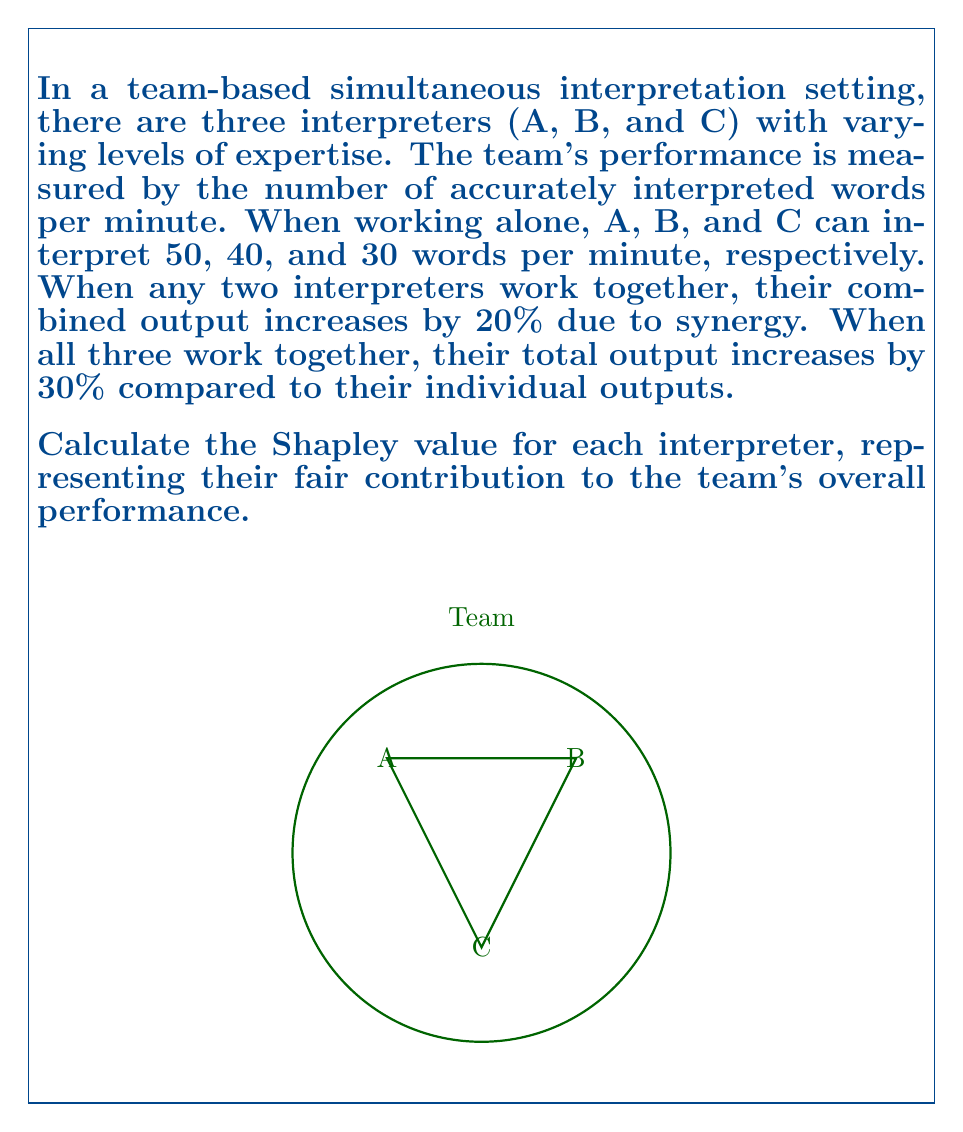Give your solution to this math problem. To calculate the Shapley value, we need to consider all possible coalitions and the marginal contributions of each interpreter. Let's follow these steps:

1. Calculate the value of each coalition:
   - v(A) = 50, v(B) = 40, v(C) = 30
   - v(AB) = (50 + 40) * 1.2 = 108
   - v(AC) = (50 + 30) * 1.2 = 96
   - v(BC) = (40 + 30) * 1.2 = 84
   - v(ABC) = (50 + 40 + 30) * 1.3 = 156

2. List all possible orderings of interpreters (6 in total):
   ABC, ACB, BAC, BCA, CAB, CBA

3. Calculate marginal contributions for each interpreter in each ordering:
   ABC: A(50), B(58), C(48)
   ACB: A(50), C(46), B(60)
   BAC: B(40), A(68), C(48)
   BCA: B(40), C(44), A(72)
   CAB: C(30), A(66), B(60)
   CBA: C(30), B(54), A(72)

4. Calculate the Shapley value for each interpreter:
   Shapley value = (sum of marginal contributions) / (number of orderings)

   For A: $\phi_A = \frac{50 + 50 + 68 + 72 + 66 + 72}{6} = 63$

   For B: $\phi_B = \frac{58 + 60 + 40 + 40 + 60 + 54}{6} = 52$

   For C: $\phi_C = \frac{48 + 46 + 48 + 44 + 30 + 30}{6} = 41$

5. Verify that the Shapley values sum up to the grand coalition value:
   $63 + 52 + 41 = 156 = v(ABC)$

The Shapley values represent the fair allocation of the team's total output to each interpreter, considering their individual skills and synergistic effects.
Answer: Shapley values: A = 63, B = 52, C = 41 